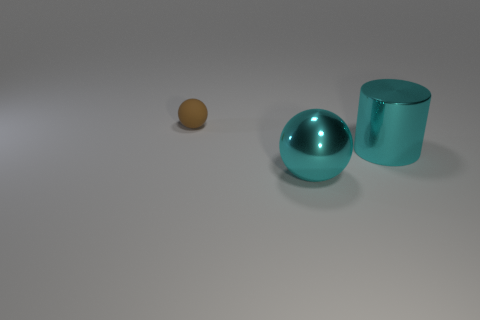Are there any large shiny cylinders that are on the right side of the ball that is in front of the small brown object?
Make the answer very short. Yes. There is a thing that is both right of the small brown sphere and on the left side of the cylinder; what size is it?
Keep it short and to the point. Large. What number of cyan objects are tiny rubber spheres or big shiny balls?
Offer a very short reply. 1. There is a cyan object that is the same size as the cyan metal cylinder; what shape is it?
Your answer should be compact. Sphere. How many other objects are the same color as the tiny matte sphere?
Your answer should be very brief. 0. There is a cyan shiny ball in front of the metal thing behind the big metal ball; what is its size?
Give a very brief answer. Large. Are the sphere right of the matte ball and the large cyan cylinder made of the same material?
Offer a very short reply. Yes. What shape is the thing that is on the left side of the large cyan metallic sphere?
Offer a very short reply. Sphere. What number of metallic cylinders are the same size as the cyan ball?
Offer a terse response. 1. The shiny ball has what size?
Your response must be concise. Large. 